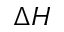<formula> <loc_0><loc_0><loc_500><loc_500>{ \Delta H }</formula> 